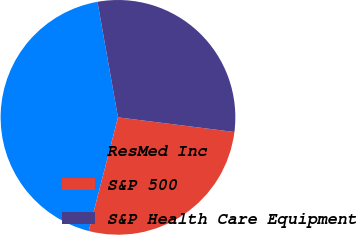<chart> <loc_0><loc_0><loc_500><loc_500><pie_chart><fcel>ResMed Inc<fcel>S&P 500<fcel>S&P Health Care Equipment<nl><fcel>43.19%<fcel>27.02%<fcel>29.79%<nl></chart> 